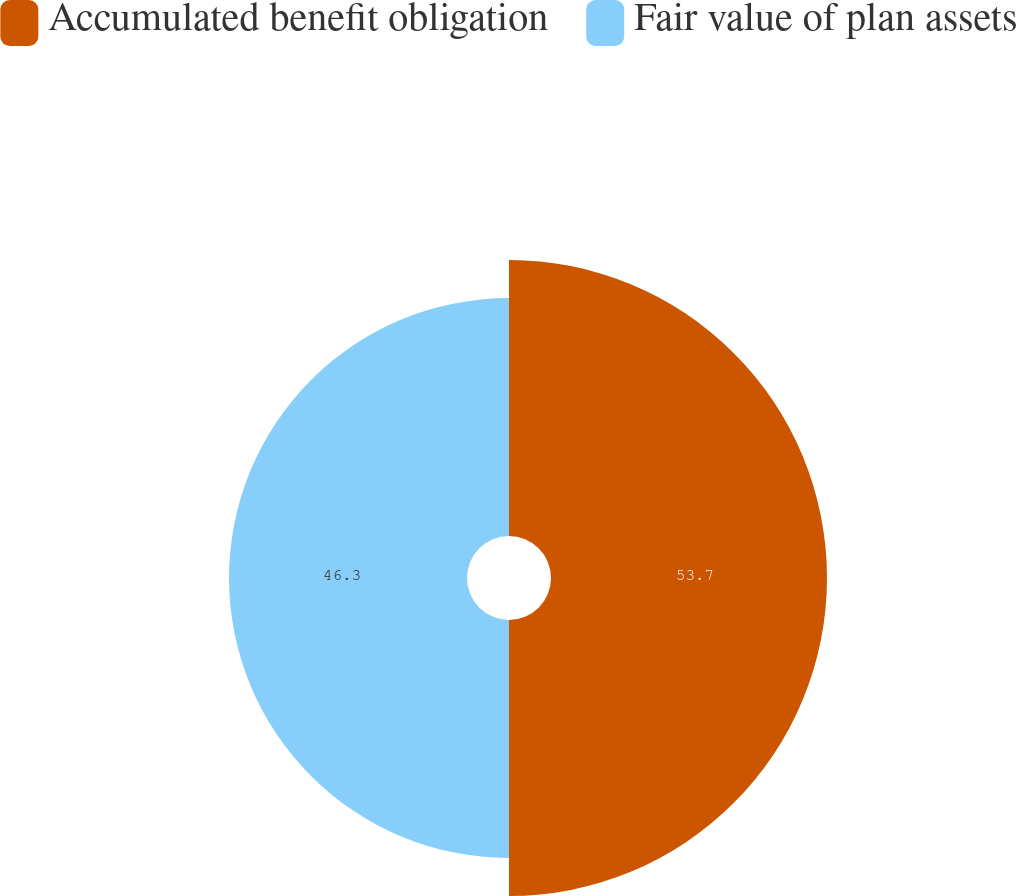Convert chart. <chart><loc_0><loc_0><loc_500><loc_500><pie_chart><fcel>Accumulated benefit obligation<fcel>Fair value of plan assets<nl><fcel>53.7%<fcel>46.3%<nl></chart> 